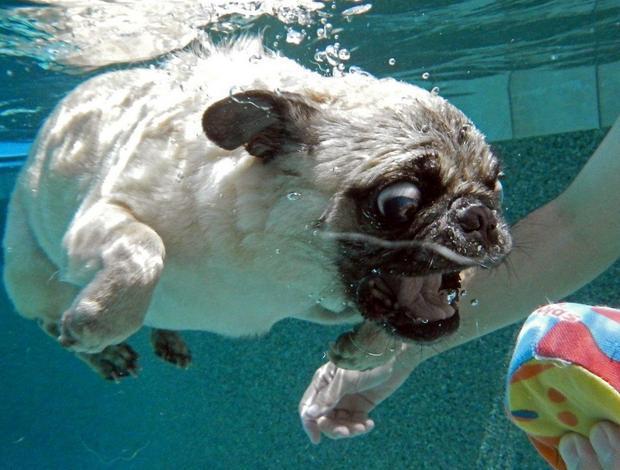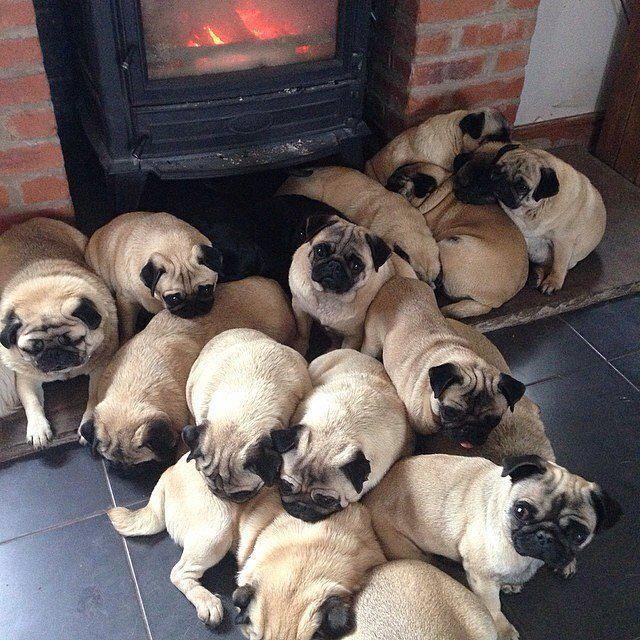The first image is the image on the left, the second image is the image on the right. For the images shown, is this caption "Exactly one pug dog is shown in a scene with water." true? Answer yes or no. Yes. 